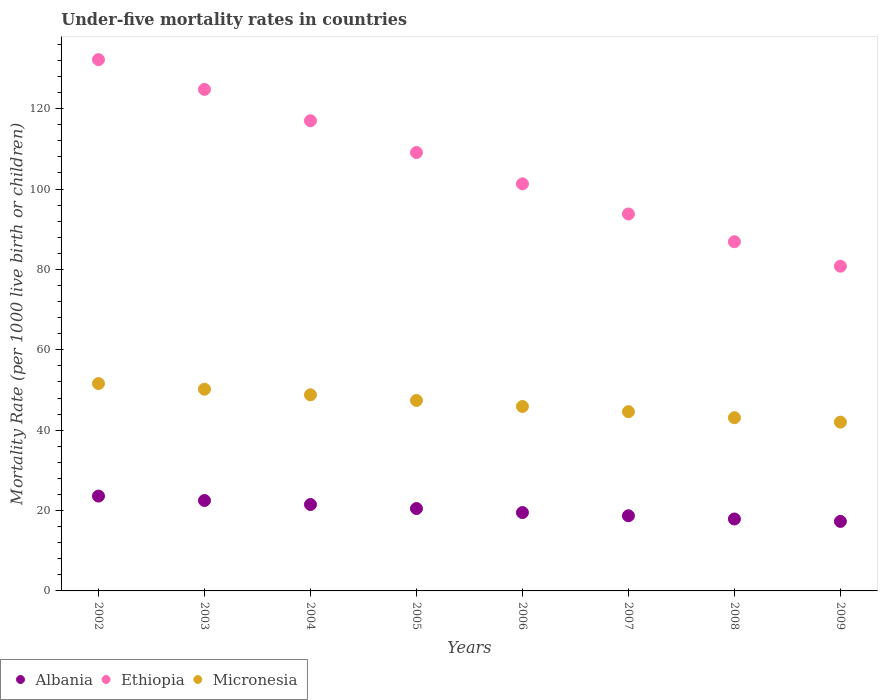How many different coloured dotlines are there?
Make the answer very short. 3. What is the under-five mortality rate in Micronesia in 2008?
Give a very brief answer. 43.1. Across all years, what is the maximum under-five mortality rate in Micronesia?
Provide a succinct answer. 51.6. Across all years, what is the minimum under-five mortality rate in Ethiopia?
Keep it short and to the point. 80.8. In which year was the under-five mortality rate in Ethiopia maximum?
Your answer should be very brief. 2002. What is the total under-five mortality rate in Albania in the graph?
Keep it short and to the point. 161.5. What is the difference between the under-five mortality rate in Ethiopia in 2004 and that in 2005?
Your response must be concise. 7.9. What is the difference between the under-five mortality rate in Ethiopia in 2002 and the under-five mortality rate in Micronesia in 2009?
Make the answer very short. 90.2. What is the average under-five mortality rate in Micronesia per year?
Give a very brief answer. 46.7. In the year 2007, what is the difference between the under-five mortality rate in Ethiopia and under-five mortality rate in Albania?
Offer a very short reply. 75.1. In how many years, is the under-five mortality rate in Ethiopia greater than 56?
Offer a terse response. 8. What is the ratio of the under-five mortality rate in Micronesia in 2004 to that in 2007?
Offer a very short reply. 1.09. Is the under-five mortality rate in Micronesia in 2005 less than that in 2009?
Offer a very short reply. No. Is the difference between the under-five mortality rate in Ethiopia in 2005 and 2009 greater than the difference between the under-five mortality rate in Albania in 2005 and 2009?
Your response must be concise. Yes. What is the difference between the highest and the second highest under-five mortality rate in Micronesia?
Offer a very short reply. 1.4. What is the difference between the highest and the lowest under-five mortality rate in Ethiopia?
Provide a short and direct response. 51.4. In how many years, is the under-five mortality rate in Ethiopia greater than the average under-five mortality rate in Ethiopia taken over all years?
Offer a very short reply. 4. Is the under-five mortality rate in Micronesia strictly less than the under-five mortality rate in Ethiopia over the years?
Provide a short and direct response. Yes. How many dotlines are there?
Keep it short and to the point. 3. What is the difference between two consecutive major ticks on the Y-axis?
Offer a terse response. 20. Are the values on the major ticks of Y-axis written in scientific E-notation?
Give a very brief answer. No. What is the title of the graph?
Keep it short and to the point. Under-five mortality rates in countries. Does "China" appear as one of the legend labels in the graph?
Your answer should be compact. No. What is the label or title of the X-axis?
Keep it short and to the point. Years. What is the label or title of the Y-axis?
Provide a succinct answer. Mortality Rate (per 1000 live birth or children). What is the Mortality Rate (per 1000 live birth or children) in Albania in 2002?
Give a very brief answer. 23.6. What is the Mortality Rate (per 1000 live birth or children) in Ethiopia in 2002?
Your answer should be very brief. 132.2. What is the Mortality Rate (per 1000 live birth or children) of Micronesia in 2002?
Provide a short and direct response. 51.6. What is the Mortality Rate (per 1000 live birth or children) of Albania in 2003?
Your response must be concise. 22.5. What is the Mortality Rate (per 1000 live birth or children) of Ethiopia in 2003?
Provide a short and direct response. 124.8. What is the Mortality Rate (per 1000 live birth or children) of Micronesia in 2003?
Provide a succinct answer. 50.2. What is the Mortality Rate (per 1000 live birth or children) in Ethiopia in 2004?
Ensure brevity in your answer.  117. What is the Mortality Rate (per 1000 live birth or children) of Micronesia in 2004?
Make the answer very short. 48.8. What is the Mortality Rate (per 1000 live birth or children) in Ethiopia in 2005?
Your response must be concise. 109.1. What is the Mortality Rate (per 1000 live birth or children) in Micronesia in 2005?
Your answer should be compact. 47.4. What is the Mortality Rate (per 1000 live birth or children) in Albania in 2006?
Your response must be concise. 19.5. What is the Mortality Rate (per 1000 live birth or children) in Ethiopia in 2006?
Your response must be concise. 101.3. What is the Mortality Rate (per 1000 live birth or children) of Micronesia in 2006?
Ensure brevity in your answer.  45.9. What is the Mortality Rate (per 1000 live birth or children) in Ethiopia in 2007?
Make the answer very short. 93.8. What is the Mortality Rate (per 1000 live birth or children) of Micronesia in 2007?
Provide a succinct answer. 44.6. What is the Mortality Rate (per 1000 live birth or children) of Albania in 2008?
Make the answer very short. 17.9. What is the Mortality Rate (per 1000 live birth or children) in Ethiopia in 2008?
Ensure brevity in your answer.  86.9. What is the Mortality Rate (per 1000 live birth or children) of Micronesia in 2008?
Make the answer very short. 43.1. What is the Mortality Rate (per 1000 live birth or children) of Albania in 2009?
Ensure brevity in your answer.  17.3. What is the Mortality Rate (per 1000 live birth or children) in Ethiopia in 2009?
Make the answer very short. 80.8. What is the Mortality Rate (per 1000 live birth or children) in Micronesia in 2009?
Make the answer very short. 42. Across all years, what is the maximum Mortality Rate (per 1000 live birth or children) in Albania?
Ensure brevity in your answer.  23.6. Across all years, what is the maximum Mortality Rate (per 1000 live birth or children) in Ethiopia?
Your answer should be compact. 132.2. Across all years, what is the maximum Mortality Rate (per 1000 live birth or children) in Micronesia?
Ensure brevity in your answer.  51.6. Across all years, what is the minimum Mortality Rate (per 1000 live birth or children) in Albania?
Give a very brief answer. 17.3. Across all years, what is the minimum Mortality Rate (per 1000 live birth or children) in Ethiopia?
Ensure brevity in your answer.  80.8. What is the total Mortality Rate (per 1000 live birth or children) in Albania in the graph?
Offer a very short reply. 161.5. What is the total Mortality Rate (per 1000 live birth or children) in Ethiopia in the graph?
Keep it short and to the point. 845.9. What is the total Mortality Rate (per 1000 live birth or children) in Micronesia in the graph?
Make the answer very short. 373.6. What is the difference between the Mortality Rate (per 1000 live birth or children) in Ethiopia in 2002 and that in 2003?
Give a very brief answer. 7.4. What is the difference between the Mortality Rate (per 1000 live birth or children) in Albania in 2002 and that in 2004?
Your response must be concise. 2.1. What is the difference between the Mortality Rate (per 1000 live birth or children) in Ethiopia in 2002 and that in 2004?
Your answer should be very brief. 15.2. What is the difference between the Mortality Rate (per 1000 live birth or children) in Micronesia in 2002 and that in 2004?
Provide a short and direct response. 2.8. What is the difference between the Mortality Rate (per 1000 live birth or children) in Ethiopia in 2002 and that in 2005?
Provide a succinct answer. 23.1. What is the difference between the Mortality Rate (per 1000 live birth or children) of Micronesia in 2002 and that in 2005?
Provide a short and direct response. 4.2. What is the difference between the Mortality Rate (per 1000 live birth or children) in Albania in 2002 and that in 2006?
Provide a succinct answer. 4.1. What is the difference between the Mortality Rate (per 1000 live birth or children) in Ethiopia in 2002 and that in 2006?
Keep it short and to the point. 30.9. What is the difference between the Mortality Rate (per 1000 live birth or children) of Ethiopia in 2002 and that in 2007?
Make the answer very short. 38.4. What is the difference between the Mortality Rate (per 1000 live birth or children) in Ethiopia in 2002 and that in 2008?
Ensure brevity in your answer.  45.3. What is the difference between the Mortality Rate (per 1000 live birth or children) of Micronesia in 2002 and that in 2008?
Offer a terse response. 8.5. What is the difference between the Mortality Rate (per 1000 live birth or children) in Albania in 2002 and that in 2009?
Provide a succinct answer. 6.3. What is the difference between the Mortality Rate (per 1000 live birth or children) of Ethiopia in 2002 and that in 2009?
Your answer should be compact. 51.4. What is the difference between the Mortality Rate (per 1000 live birth or children) in Micronesia in 2002 and that in 2009?
Provide a succinct answer. 9.6. What is the difference between the Mortality Rate (per 1000 live birth or children) of Ethiopia in 2003 and that in 2004?
Your answer should be compact. 7.8. What is the difference between the Mortality Rate (per 1000 live birth or children) in Micronesia in 2003 and that in 2004?
Give a very brief answer. 1.4. What is the difference between the Mortality Rate (per 1000 live birth or children) in Ethiopia in 2003 and that in 2005?
Provide a succinct answer. 15.7. What is the difference between the Mortality Rate (per 1000 live birth or children) in Albania in 2003 and that in 2006?
Make the answer very short. 3. What is the difference between the Mortality Rate (per 1000 live birth or children) in Ethiopia in 2003 and that in 2006?
Provide a succinct answer. 23.5. What is the difference between the Mortality Rate (per 1000 live birth or children) in Micronesia in 2003 and that in 2006?
Provide a succinct answer. 4.3. What is the difference between the Mortality Rate (per 1000 live birth or children) in Albania in 2003 and that in 2007?
Offer a terse response. 3.8. What is the difference between the Mortality Rate (per 1000 live birth or children) of Micronesia in 2003 and that in 2007?
Provide a short and direct response. 5.6. What is the difference between the Mortality Rate (per 1000 live birth or children) of Albania in 2003 and that in 2008?
Offer a terse response. 4.6. What is the difference between the Mortality Rate (per 1000 live birth or children) in Ethiopia in 2003 and that in 2008?
Give a very brief answer. 37.9. What is the difference between the Mortality Rate (per 1000 live birth or children) in Albania in 2003 and that in 2009?
Provide a short and direct response. 5.2. What is the difference between the Mortality Rate (per 1000 live birth or children) in Ethiopia in 2003 and that in 2009?
Your answer should be very brief. 44. What is the difference between the Mortality Rate (per 1000 live birth or children) in Ethiopia in 2004 and that in 2005?
Give a very brief answer. 7.9. What is the difference between the Mortality Rate (per 1000 live birth or children) in Albania in 2004 and that in 2006?
Make the answer very short. 2. What is the difference between the Mortality Rate (per 1000 live birth or children) of Ethiopia in 2004 and that in 2006?
Offer a terse response. 15.7. What is the difference between the Mortality Rate (per 1000 live birth or children) in Albania in 2004 and that in 2007?
Give a very brief answer. 2.8. What is the difference between the Mortality Rate (per 1000 live birth or children) of Ethiopia in 2004 and that in 2007?
Ensure brevity in your answer.  23.2. What is the difference between the Mortality Rate (per 1000 live birth or children) of Micronesia in 2004 and that in 2007?
Your answer should be very brief. 4.2. What is the difference between the Mortality Rate (per 1000 live birth or children) in Albania in 2004 and that in 2008?
Make the answer very short. 3.6. What is the difference between the Mortality Rate (per 1000 live birth or children) of Ethiopia in 2004 and that in 2008?
Your answer should be compact. 30.1. What is the difference between the Mortality Rate (per 1000 live birth or children) in Micronesia in 2004 and that in 2008?
Offer a very short reply. 5.7. What is the difference between the Mortality Rate (per 1000 live birth or children) in Albania in 2004 and that in 2009?
Make the answer very short. 4.2. What is the difference between the Mortality Rate (per 1000 live birth or children) in Ethiopia in 2004 and that in 2009?
Offer a very short reply. 36.2. What is the difference between the Mortality Rate (per 1000 live birth or children) in Ethiopia in 2005 and that in 2006?
Make the answer very short. 7.8. What is the difference between the Mortality Rate (per 1000 live birth or children) in Albania in 2005 and that in 2009?
Make the answer very short. 3.2. What is the difference between the Mortality Rate (per 1000 live birth or children) of Ethiopia in 2005 and that in 2009?
Your answer should be compact. 28.3. What is the difference between the Mortality Rate (per 1000 live birth or children) of Micronesia in 2006 and that in 2007?
Give a very brief answer. 1.3. What is the difference between the Mortality Rate (per 1000 live birth or children) of Albania in 2006 and that in 2008?
Keep it short and to the point. 1.6. What is the difference between the Mortality Rate (per 1000 live birth or children) of Ethiopia in 2006 and that in 2008?
Make the answer very short. 14.4. What is the difference between the Mortality Rate (per 1000 live birth or children) of Micronesia in 2006 and that in 2009?
Give a very brief answer. 3.9. What is the difference between the Mortality Rate (per 1000 live birth or children) of Albania in 2007 and that in 2009?
Provide a short and direct response. 1.4. What is the difference between the Mortality Rate (per 1000 live birth or children) of Ethiopia in 2007 and that in 2009?
Your answer should be very brief. 13. What is the difference between the Mortality Rate (per 1000 live birth or children) of Micronesia in 2008 and that in 2009?
Provide a succinct answer. 1.1. What is the difference between the Mortality Rate (per 1000 live birth or children) in Albania in 2002 and the Mortality Rate (per 1000 live birth or children) in Ethiopia in 2003?
Offer a terse response. -101.2. What is the difference between the Mortality Rate (per 1000 live birth or children) in Albania in 2002 and the Mortality Rate (per 1000 live birth or children) in Micronesia in 2003?
Provide a succinct answer. -26.6. What is the difference between the Mortality Rate (per 1000 live birth or children) in Ethiopia in 2002 and the Mortality Rate (per 1000 live birth or children) in Micronesia in 2003?
Your answer should be very brief. 82. What is the difference between the Mortality Rate (per 1000 live birth or children) in Albania in 2002 and the Mortality Rate (per 1000 live birth or children) in Ethiopia in 2004?
Your response must be concise. -93.4. What is the difference between the Mortality Rate (per 1000 live birth or children) of Albania in 2002 and the Mortality Rate (per 1000 live birth or children) of Micronesia in 2004?
Your answer should be very brief. -25.2. What is the difference between the Mortality Rate (per 1000 live birth or children) in Ethiopia in 2002 and the Mortality Rate (per 1000 live birth or children) in Micronesia in 2004?
Ensure brevity in your answer.  83.4. What is the difference between the Mortality Rate (per 1000 live birth or children) in Albania in 2002 and the Mortality Rate (per 1000 live birth or children) in Ethiopia in 2005?
Offer a very short reply. -85.5. What is the difference between the Mortality Rate (per 1000 live birth or children) in Albania in 2002 and the Mortality Rate (per 1000 live birth or children) in Micronesia in 2005?
Ensure brevity in your answer.  -23.8. What is the difference between the Mortality Rate (per 1000 live birth or children) of Ethiopia in 2002 and the Mortality Rate (per 1000 live birth or children) of Micronesia in 2005?
Keep it short and to the point. 84.8. What is the difference between the Mortality Rate (per 1000 live birth or children) in Albania in 2002 and the Mortality Rate (per 1000 live birth or children) in Ethiopia in 2006?
Your response must be concise. -77.7. What is the difference between the Mortality Rate (per 1000 live birth or children) of Albania in 2002 and the Mortality Rate (per 1000 live birth or children) of Micronesia in 2006?
Provide a succinct answer. -22.3. What is the difference between the Mortality Rate (per 1000 live birth or children) in Ethiopia in 2002 and the Mortality Rate (per 1000 live birth or children) in Micronesia in 2006?
Your response must be concise. 86.3. What is the difference between the Mortality Rate (per 1000 live birth or children) in Albania in 2002 and the Mortality Rate (per 1000 live birth or children) in Ethiopia in 2007?
Provide a succinct answer. -70.2. What is the difference between the Mortality Rate (per 1000 live birth or children) in Albania in 2002 and the Mortality Rate (per 1000 live birth or children) in Micronesia in 2007?
Give a very brief answer. -21. What is the difference between the Mortality Rate (per 1000 live birth or children) in Ethiopia in 2002 and the Mortality Rate (per 1000 live birth or children) in Micronesia in 2007?
Keep it short and to the point. 87.6. What is the difference between the Mortality Rate (per 1000 live birth or children) in Albania in 2002 and the Mortality Rate (per 1000 live birth or children) in Ethiopia in 2008?
Your answer should be very brief. -63.3. What is the difference between the Mortality Rate (per 1000 live birth or children) in Albania in 2002 and the Mortality Rate (per 1000 live birth or children) in Micronesia in 2008?
Ensure brevity in your answer.  -19.5. What is the difference between the Mortality Rate (per 1000 live birth or children) of Ethiopia in 2002 and the Mortality Rate (per 1000 live birth or children) of Micronesia in 2008?
Provide a short and direct response. 89.1. What is the difference between the Mortality Rate (per 1000 live birth or children) of Albania in 2002 and the Mortality Rate (per 1000 live birth or children) of Ethiopia in 2009?
Ensure brevity in your answer.  -57.2. What is the difference between the Mortality Rate (per 1000 live birth or children) of Albania in 2002 and the Mortality Rate (per 1000 live birth or children) of Micronesia in 2009?
Your answer should be compact. -18.4. What is the difference between the Mortality Rate (per 1000 live birth or children) of Ethiopia in 2002 and the Mortality Rate (per 1000 live birth or children) of Micronesia in 2009?
Your answer should be compact. 90.2. What is the difference between the Mortality Rate (per 1000 live birth or children) of Albania in 2003 and the Mortality Rate (per 1000 live birth or children) of Ethiopia in 2004?
Give a very brief answer. -94.5. What is the difference between the Mortality Rate (per 1000 live birth or children) in Albania in 2003 and the Mortality Rate (per 1000 live birth or children) in Micronesia in 2004?
Give a very brief answer. -26.3. What is the difference between the Mortality Rate (per 1000 live birth or children) in Ethiopia in 2003 and the Mortality Rate (per 1000 live birth or children) in Micronesia in 2004?
Provide a short and direct response. 76. What is the difference between the Mortality Rate (per 1000 live birth or children) of Albania in 2003 and the Mortality Rate (per 1000 live birth or children) of Ethiopia in 2005?
Keep it short and to the point. -86.6. What is the difference between the Mortality Rate (per 1000 live birth or children) of Albania in 2003 and the Mortality Rate (per 1000 live birth or children) of Micronesia in 2005?
Ensure brevity in your answer.  -24.9. What is the difference between the Mortality Rate (per 1000 live birth or children) in Ethiopia in 2003 and the Mortality Rate (per 1000 live birth or children) in Micronesia in 2005?
Your answer should be very brief. 77.4. What is the difference between the Mortality Rate (per 1000 live birth or children) in Albania in 2003 and the Mortality Rate (per 1000 live birth or children) in Ethiopia in 2006?
Offer a terse response. -78.8. What is the difference between the Mortality Rate (per 1000 live birth or children) in Albania in 2003 and the Mortality Rate (per 1000 live birth or children) in Micronesia in 2006?
Your answer should be compact. -23.4. What is the difference between the Mortality Rate (per 1000 live birth or children) in Ethiopia in 2003 and the Mortality Rate (per 1000 live birth or children) in Micronesia in 2006?
Your response must be concise. 78.9. What is the difference between the Mortality Rate (per 1000 live birth or children) of Albania in 2003 and the Mortality Rate (per 1000 live birth or children) of Ethiopia in 2007?
Make the answer very short. -71.3. What is the difference between the Mortality Rate (per 1000 live birth or children) of Albania in 2003 and the Mortality Rate (per 1000 live birth or children) of Micronesia in 2007?
Keep it short and to the point. -22.1. What is the difference between the Mortality Rate (per 1000 live birth or children) in Ethiopia in 2003 and the Mortality Rate (per 1000 live birth or children) in Micronesia in 2007?
Provide a succinct answer. 80.2. What is the difference between the Mortality Rate (per 1000 live birth or children) of Albania in 2003 and the Mortality Rate (per 1000 live birth or children) of Ethiopia in 2008?
Your response must be concise. -64.4. What is the difference between the Mortality Rate (per 1000 live birth or children) of Albania in 2003 and the Mortality Rate (per 1000 live birth or children) of Micronesia in 2008?
Provide a short and direct response. -20.6. What is the difference between the Mortality Rate (per 1000 live birth or children) of Ethiopia in 2003 and the Mortality Rate (per 1000 live birth or children) of Micronesia in 2008?
Ensure brevity in your answer.  81.7. What is the difference between the Mortality Rate (per 1000 live birth or children) in Albania in 2003 and the Mortality Rate (per 1000 live birth or children) in Ethiopia in 2009?
Give a very brief answer. -58.3. What is the difference between the Mortality Rate (per 1000 live birth or children) of Albania in 2003 and the Mortality Rate (per 1000 live birth or children) of Micronesia in 2009?
Provide a short and direct response. -19.5. What is the difference between the Mortality Rate (per 1000 live birth or children) of Ethiopia in 2003 and the Mortality Rate (per 1000 live birth or children) of Micronesia in 2009?
Your answer should be very brief. 82.8. What is the difference between the Mortality Rate (per 1000 live birth or children) in Albania in 2004 and the Mortality Rate (per 1000 live birth or children) in Ethiopia in 2005?
Provide a short and direct response. -87.6. What is the difference between the Mortality Rate (per 1000 live birth or children) in Albania in 2004 and the Mortality Rate (per 1000 live birth or children) in Micronesia in 2005?
Your answer should be very brief. -25.9. What is the difference between the Mortality Rate (per 1000 live birth or children) in Ethiopia in 2004 and the Mortality Rate (per 1000 live birth or children) in Micronesia in 2005?
Give a very brief answer. 69.6. What is the difference between the Mortality Rate (per 1000 live birth or children) of Albania in 2004 and the Mortality Rate (per 1000 live birth or children) of Ethiopia in 2006?
Your answer should be compact. -79.8. What is the difference between the Mortality Rate (per 1000 live birth or children) of Albania in 2004 and the Mortality Rate (per 1000 live birth or children) of Micronesia in 2006?
Make the answer very short. -24.4. What is the difference between the Mortality Rate (per 1000 live birth or children) of Ethiopia in 2004 and the Mortality Rate (per 1000 live birth or children) of Micronesia in 2006?
Your answer should be compact. 71.1. What is the difference between the Mortality Rate (per 1000 live birth or children) of Albania in 2004 and the Mortality Rate (per 1000 live birth or children) of Ethiopia in 2007?
Your answer should be compact. -72.3. What is the difference between the Mortality Rate (per 1000 live birth or children) in Albania in 2004 and the Mortality Rate (per 1000 live birth or children) in Micronesia in 2007?
Your answer should be compact. -23.1. What is the difference between the Mortality Rate (per 1000 live birth or children) in Ethiopia in 2004 and the Mortality Rate (per 1000 live birth or children) in Micronesia in 2007?
Ensure brevity in your answer.  72.4. What is the difference between the Mortality Rate (per 1000 live birth or children) of Albania in 2004 and the Mortality Rate (per 1000 live birth or children) of Ethiopia in 2008?
Offer a very short reply. -65.4. What is the difference between the Mortality Rate (per 1000 live birth or children) in Albania in 2004 and the Mortality Rate (per 1000 live birth or children) in Micronesia in 2008?
Ensure brevity in your answer.  -21.6. What is the difference between the Mortality Rate (per 1000 live birth or children) in Ethiopia in 2004 and the Mortality Rate (per 1000 live birth or children) in Micronesia in 2008?
Offer a very short reply. 73.9. What is the difference between the Mortality Rate (per 1000 live birth or children) in Albania in 2004 and the Mortality Rate (per 1000 live birth or children) in Ethiopia in 2009?
Keep it short and to the point. -59.3. What is the difference between the Mortality Rate (per 1000 live birth or children) in Albania in 2004 and the Mortality Rate (per 1000 live birth or children) in Micronesia in 2009?
Offer a very short reply. -20.5. What is the difference between the Mortality Rate (per 1000 live birth or children) of Albania in 2005 and the Mortality Rate (per 1000 live birth or children) of Ethiopia in 2006?
Your answer should be compact. -80.8. What is the difference between the Mortality Rate (per 1000 live birth or children) of Albania in 2005 and the Mortality Rate (per 1000 live birth or children) of Micronesia in 2006?
Provide a succinct answer. -25.4. What is the difference between the Mortality Rate (per 1000 live birth or children) of Ethiopia in 2005 and the Mortality Rate (per 1000 live birth or children) of Micronesia in 2006?
Ensure brevity in your answer.  63.2. What is the difference between the Mortality Rate (per 1000 live birth or children) of Albania in 2005 and the Mortality Rate (per 1000 live birth or children) of Ethiopia in 2007?
Offer a terse response. -73.3. What is the difference between the Mortality Rate (per 1000 live birth or children) of Albania in 2005 and the Mortality Rate (per 1000 live birth or children) of Micronesia in 2007?
Ensure brevity in your answer.  -24.1. What is the difference between the Mortality Rate (per 1000 live birth or children) in Ethiopia in 2005 and the Mortality Rate (per 1000 live birth or children) in Micronesia in 2007?
Make the answer very short. 64.5. What is the difference between the Mortality Rate (per 1000 live birth or children) in Albania in 2005 and the Mortality Rate (per 1000 live birth or children) in Ethiopia in 2008?
Provide a short and direct response. -66.4. What is the difference between the Mortality Rate (per 1000 live birth or children) of Albania in 2005 and the Mortality Rate (per 1000 live birth or children) of Micronesia in 2008?
Ensure brevity in your answer.  -22.6. What is the difference between the Mortality Rate (per 1000 live birth or children) in Albania in 2005 and the Mortality Rate (per 1000 live birth or children) in Ethiopia in 2009?
Ensure brevity in your answer.  -60.3. What is the difference between the Mortality Rate (per 1000 live birth or children) in Albania in 2005 and the Mortality Rate (per 1000 live birth or children) in Micronesia in 2009?
Provide a short and direct response. -21.5. What is the difference between the Mortality Rate (per 1000 live birth or children) of Ethiopia in 2005 and the Mortality Rate (per 1000 live birth or children) of Micronesia in 2009?
Your response must be concise. 67.1. What is the difference between the Mortality Rate (per 1000 live birth or children) of Albania in 2006 and the Mortality Rate (per 1000 live birth or children) of Ethiopia in 2007?
Your answer should be compact. -74.3. What is the difference between the Mortality Rate (per 1000 live birth or children) in Albania in 2006 and the Mortality Rate (per 1000 live birth or children) in Micronesia in 2007?
Make the answer very short. -25.1. What is the difference between the Mortality Rate (per 1000 live birth or children) of Ethiopia in 2006 and the Mortality Rate (per 1000 live birth or children) of Micronesia in 2007?
Keep it short and to the point. 56.7. What is the difference between the Mortality Rate (per 1000 live birth or children) in Albania in 2006 and the Mortality Rate (per 1000 live birth or children) in Ethiopia in 2008?
Ensure brevity in your answer.  -67.4. What is the difference between the Mortality Rate (per 1000 live birth or children) of Albania in 2006 and the Mortality Rate (per 1000 live birth or children) of Micronesia in 2008?
Provide a succinct answer. -23.6. What is the difference between the Mortality Rate (per 1000 live birth or children) in Ethiopia in 2006 and the Mortality Rate (per 1000 live birth or children) in Micronesia in 2008?
Give a very brief answer. 58.2. What is the difference between the Mortality Rate (per 1000 live birth or children) of Albania in 2006 and the Mortality Rate (per 1000 live birth or children) of Ethiopia in 2009?
Your answer should be very brief. -61.3. What is the difference between the Mortality Rate (per 1000 live birth or children) of Albania in 2006 and the Mortality Rate (per 1000 live birth or children) of Micronesia in 2009?
Keep it short and to the point. -22.5. What is the difference between the Mortality Rate (per 1000 live birth or children) in Ethiopia in 2006 and the Mortality Rate (per 1000 live birth or children) in Micronesia in 2009?
Offer a terse response. 59.3. What is the difference between the Mortality Rate (per 1000 live birth or children) in Albania in 2007 and the Mortality Rate (per 1000 live birth or children) in Ethiopia in 2008?
Provide a short and direct response. -68.2. What is the difference between the Mortality Rate (per 1000 live birth or children) in Albania in 2007 and the Mortality Rate (per 1000 live birth or children) in Micronesia in 2008?
Your response must be concise. -24.4. What is the difference between the Mortality Rate (per 1000 live birth or children) of Ethiopia in 2007 and the Mortality Rate (per 1000 live birth or children) of Micronesia in 2008?
Give a very brief answer. 50.7. What is the difference between the Mortality Rate (per 1000 live birth or children) of Albania in 2007 and the Mortality Rate (per 1000 live birth or children) of Ethiopia in 2009?
Offer a very short reply. -62.1. What is the difference between the Mortality Rate (per 1000 live birth or children) of Albania in 2007 and the Mortality Rate (per 1000 live birth or children) of Micronesia in 2009?
Your response must be concise. -23.3. What is the difference between the Mortality Rate (per 1000 live birth or children) of Ethiopia in 2007 and the Mortality Rate (per 1000 live birth or children) of Micronesia in 2009?
Offer a terse response. 51.8. What is the difference between the Mortality Rate (per 1000 live birth or children) of Albania in 2008 and the Mortality Rate (per 1000 live birth or children) of Ethiopia in 2009?
Your response must be concise. -62.9. What is the difference between the Mortality Rate (per 1000 live birth or children) in Albania in 2008 and the Mortality Rate (per 1000 live birth or children) in Micronesia in 2009?
Keep it short and to the point. -24.1. What is the difference between the Mortality Rate (per 1000 live birth or children) of Ethiopia in 2008 and the Mortality Rate (per 1000 live birth or children) of Micronesia in 2009?
Provide a succinct answer. 44.9. What is the average Mortality Rate (per 1000 live birth or children) in Albania per year?
Offer a very short reply. 20.19. What is the average Mortality Rate (per 1000 live birth or children) of Ethiopia per year?
Your answer should be very brief. 105.74. What is the average Mortality Rate (per 1000 live birth or children) in Micronesia per year?
Your answer should be very brief. 46.7. In the year 2002, what is the difference between the Mortality Rate (per 1000 live birth or children) of Albania and Mortality Rate (per 1000 live birth or children) of Ethiopia?
Your answer should be very brief. -108.6. In the year 2002, what is the difference between the Mortality Rate (per 1000 live birth or children) of Albania and Mortality Rate (per 1000 live birth or children) of Micronesia?
Provide a succinct answer. -28. In the year 2002, what is the difference between the Mortality Rate (per 1000 live birth or children) in Ethiopia and Mortality Rate (per 1000 live birth or children) in Micronesia?
Offer a very short reply. 80.6. In the year 2003, what is the difference between the Mortality Rate (per 1000 live birth or children) of Albania and Mortality Rate (per 1000 live birth or children) of Ethiopia?
Keep it short and to the point. -102.3. In the year 2003, what is the difference between the Mortality Rate (per 1000 live birth or children) of Albania and Mortality Rate (per 1000 live birth or children) of Micronesia?
Your answer should be compact. -27.7. In the year 2003, what is the difference between the Mortality Rate (per 1000 live birth or children) in Ethiopia and Mortality Rate (per 1000 live birth or children) in Micronesia?
Ensure brevity in your answer.  74.6. In the year 2004, what is the difference between the Mortality Rate (per 1000 live birth or children) in Albania and Mortality Rate (per 1000 live birth or children) in Ethiopia?
Your response must be concise. -95.5. In the year 2004, what is the difference between the Mortality Rate (per 1000 live birth or children) of Albania and Mortality Rate (per 1000 live birth or children) of Micronesia?
Give a very brief answer. -27.3. In the year 2004, what is the difference between the Mortality Rate (per 1000 live birth or children) in Ethiopia and Mortality Rate (per 1000 live birth or children) in Micronesia?
Give a very brief answer. 68.2. In the year 2005, what is the difference between the Mortality Rate (per 1000 live birth or children) in Albania and Mortality Rate (per 1000 live birth or children) in Ethiopia?
Offer a terse response. -88.6. In the year 2005, what is the difference between the Mortality Rate (per 1000 live birth or children) in Albania and Mortality Rate (per 1000 live birth or children) in Micronesia?
Offer a terse response. -26.9. In the year 2005, what is the difference between the Mortality Rate (per 1000 live birth or children) in Ethiopia and Mortality Rate (per 1000 live birth or children) in Micronesia?
Provide a succinct answer. 61.7. In the year 2006, what is the difference between the Mortality Rate (per 1000 live birth or children) in Albania and Mortality Rate (per 1000 live birth or children) in Ethiopia?
Your answer should be very brief. -81.8. In the year 2006, what is the difference between the Mortality Rate (per 1000 live birth or children) of Albania and Mortality Rate (per 1000 live birth or children) of Micronesia?
Offer a terse response. -26.4. In the year 2006, what is the difference between the Mortality Rate (per 1000 live birth or children) of Ethiopia and Mortality Rate (per 1000 live birth or children) of Micronesia?
Give a very brief answer. 55.4. In the year 2007, what is the difference between the Mortality Rate (per 1000 live birth or children) of Albania and Mortality Rate (per 1000 live birth or children) of Ethiopia?
Offer a terse response. -75.1. In the year 2007, what is the difference between the Mortality Rate (per 1000 live birth or children) of Albania and Mortality Rate (per 1000 live birth or children) of Micronesia?
Give a very brief answer. -25.9. In the year 2007, what is the difference between the Mortality Rate (per 1000 live birth or children) in Ethiopia and Mortality Rate (per 1000 live birth or children) in Micronesia?
Offer a very short reply. 49.2. In the year 2008, what is the difference between the Mortality Rate (per 1000 live birth or children) in Albania and Mortality Rate (per 1000 live birth or children) in Ethiopia?
Keep it short and to the point. -69. In the year 2008, what is the difference between the Mortality Rate (per 1000 live birth or children) in Albania and Mortality Rate (per 1000 live birth or children) in Micronesia?
Your response must be concise. -25.2. In the year 2008, what is the difference between the Mortality Rate (per 1000 live birth or children) of Ethiopia and Mortality Rate (per 1000 live birth or children) of Micronesia?
Give a very brief answer. 43.8. In the year 2009, what is the difference between the Mortality Rate (per 1000 live birth or children) in Albania and Mortality Rate (per 1000 live birth or children) in Ethiopia?
Offer a very short reply. -63.5. In the year 2009, what is the difference between the Mortality Rate (per 1000 live birth or children) in Albania and Mortality Rate (per 1000 live birth or children) in Micronesia?
Your response must be concise. -24.7. In the year 2009, what is the difference between the Mortality Rate (per 1000 live birth or children) in Ethiopia and Mortality Rate (per 1000 live birth or children) in Micronesia?
Ensure brevity in your answer.  38.8. What is the ratio of the Mortality Rate (per 1000 live birth or children) in Albania in 2002 to that in 2003?
Your answer should be very brief. 1.05. What is the ratio of the Mortality Rate (per 1000 live birth or children) of Ethiopia in 2002 to that in 2003?
Your answer should be compact. 1.06. What is the ratio of the Mortality Rate (per 1000 live birth or children) in Micronesia in 2002 to that in 2003?
Give a very brief answer. 1.03. What is the ratio of the Mortality Rate (per 1000 live birth or children) of Albania in 2002 to that in 2004?
Offer a terse response. 1.1. What is the ratio of the Mortality Rate (per 1000 live birth or children) of Ethiopia in 2002 to that in 2004?
Your answer should be compact. 1.13. What is the ratio of the Mortality Rate (per 1000 live birth or children) in Micronesia in 2002 to that in 2004?
Your response must be concise. 1.06. What is the ratio of the Mortality Rate (per 1000 live birth or children) of Albania in 2002 to that in 2005?
Your answer should be very brief. 1.15. What is the ratio of the Mortality Rate (per 1000 live birth or children) in Ethiopia in 2002 to that in 2005?
Make the answer very short. 1.21. What is the ratio of the Mortality Rate (per 1000 live birth or children) in Micronesia in 2002 to that in 2005?
Offer a terse response. 1.09. What is the ratio of the Mortality Rate (per 1000 live birth or children) in Albania in 2002 to that in 2006?
Provide a short and direct response. 1.21. What is the ratio of the Mortality Rate (per 1000 live birth or children) of Ethiopia in 2002 to that in 2006?
Offer a very short reply. 1.3. What is the ratio of the Mortality Rate (per 1000 live birth or children) in Micronesia in 2002 to that in 2006?
Offer a terse response. 1.12. What is the ratio of the Mortality Rate (per 1000 live birth or children) of Albania in 2002 to that in 2007?
Provide a succinct answer. 1.26. What is the ratio of the Mortality Rate (per 1000 live birth or children) in Ethiopia in 2002 to that in 2007?
Give a very brief answer. 1.41. What is the ratio of the Mortality Rate (per 1000 live birth or children) of Micronesia in 2002 to that in 2007?
Offer a terse response. 1.16. What is the ratio of the Mortality Rate (per 1000 live birth or children) in Albania in 2002 to that in 2008?
Make the answer very short. 1.32. What is the ratio of the Mortality Rate (per 1000 live birth or children) of Ethiopia in 2002 to that in 2008?
Keep it short and to the point. 1.52. What is the ratio of the Mortality Rate (per 1000 live birth or children) of Micronesia in 2002 to that in 2008?
Offer a very short reply. 1.2. What is the ratio of the Mortality Rate (per 1000 live birth or children) in Albania in 2002 to that in 2009?
Make the answer very short. 1.36. What is the ratio of the Mortality Rate (per 1000 live birth or children) in Ethiopia in 2002 to that in 2009?
Provide a short and direct response. 1.64. What is the ratio of the Mortality Rate (per 1000 live birth or children) in Micronesia in 2002 to that in 2009?
Offer a terse response. 1.23. What is the ratio of the Mortality Rate (per 1000 live birth or children) in Albania in 2003 to that in 2004?
Offer a terse response. 1.05. What is the ratio of the Mortality Rate (per 1000 live birth or children) in Ethiopia in 2003 to that in 2004?
Your response must be concise. 1.07. What is the ratio of the Mortality Rate (per 1000 live birth or children) in Micronesia in 2003 to that in 2004?
Keep it short and to the point. 1.03. What is the ratio of the Mortality Rate (per 1000 live birth or children) in Albania in 2003 to that in 2005?
Provide a succinct answer. 1.1. What is the ratio of the Mortality Rate (per 1000 live birth or children) in Ethiopia in 2003 to that in 2005?
Your response must be concise. 1.14. What is the ratio of the Mortality Rate (per 1000 live birth or children) of Micronesia in 2003 to that in 2005?
Your answer should be very brief. 1.06. What is the ratio of the Mortality Rate (per 1000 live birth or children) of Albania in 2003 to that in 2006?
Keep it short and to the point. 1.15. What is the ratio of the Mortality Rate (per 1000 live birth or children) of Ethiopia in 2003 to that in 2006?
Your response must be concise. 1.23. What is the ratio of the Mortality Rate (per 1000 live birth or children) in Micronesia in 2003 to that in 2006?
Provide a short and direct response. 1.09. What is the ratio of the Mortality Rate (per 1000 live birth or children) of Albania in 2003 to that in 2007?
Make the answer very short. 1.2. What is the ratio of the Mortality Rate (per 1000 live birth or children) of Ethiopia in 2003 to that in 2007?
Make the answer very short. 1.33. What is the ratio of the Mortality Rate (per 1000 live birth or children) in Micronesia in 2003 to that in 2007?
Ensure brevity in your answer.  1.13. What is the ratio of the Mortality Rate (per 1000 live birth or children) of Albania in 2003 to that in 2008?
Your answer should be very brief. 1.26. What is the ratio of the Mortality Rate (per 1000 live birth or children) of Ethiopia in 2003 to that in 2008?
Your answer should be very brief. 1.44. What is the ratio of the Mortality Rate (per 1000 live birth or children) of Micronesia in 2003 to that in 2008?
Your answer should be compact. 1.16. What is the ratio of the Mortality Rate (per 1000 live birth or children) of Albania in 2003 to that in 2009?
Your response must be concise. 1.3. What is the ratio of the Mortality Rate (per 1000 live birth or children) of Ethiopia in 2003 to that in 2009?
Provide a short and direct response. 1.54. What is the ratio of the Mortality Rate (per 1000 live birth or children) of Micronesia in 2003 to that in 2009?
Offer a terse response. 1.2. What is the ratio of the Mortality Rate (per 1000 live birth or children) in Albania in 2004 to that in 2005?
Offer a very short reply. 1.05. What is the ratio of the Mortality Rate (per 1000 live birth or children) in Ethiopia in 2004 to that in 2005?
Offer a very short reply. 1.07. What is the ratio of the Mortality Rate (per 1000 live birth or children) of Micronesia in 2004 to that in 2005?
Your answer should be very brief. 1.03. What is the ratio of the Mortality Rate (per 1000 live birth or children) of Albania in 2004 to that in 2006?
Make the answer very short. 1.1. What is the ratio of the Mortality Rate (per 1000 live birth or children) in Ethiopia in 2004 to that in 2006?
Your answer should be compact. 1.16. What is the ratio of the Mortality Rate (per 1000 live birth or children) of Micronesia in 2004 to that in 2006?
Keep it short and to the point. 1.06. What is the ratio of the Mortality Rate (per 1000 live birth or children) of Albania in 2004 to that in 2007?
Ensure brevity in your answer.  1.15. What is the ratio of the Mortality Rate (per 1000 live birth or children) in Ethiopia in 2004 to that in 2007?
Give a very brief answer. 1.25. What is the ratio of the Mortality Rate (per 1000 live birth or children) in Micronesia in 2004 to that in 2007?
Make the answer very short. 1.09. What is the ratio of the Mortality Rate (per 1000 live birth or children) of Albania in 2004 to that in 2008?
Provide a succinct answer. 1.2. What is the ratio of the Mortality Rate (per 1000 live birth or children) of Ethiopia in 2004 to that in 2008?
Your answer should be very brief. 1.35. What is the ratio of the Mortality Rate (per 1000 live birth or children) in Micronesia in 2004 to that in 2008?
Provide a succinct answer. 1.13. What is the ratio of the Mortality Rate (per 1000 live birth or children) in Albania in 2004 to that in 2009?
Make the answer very short. 1.24. What is the ratio of the Mortality Rate (per 1000 live birth or children) in Ethiopia in 2004 to that in 2009?
Provide a succinct answer. 1.45. What is the ratio of the Mortality Rate (per 1000 live birth or children) of Micronesia in 2004 to that in 2009?
Ensure brevity in your answer.  1.16. What is the ratio of the Mortality Rate (per 1000 live birth or children) in Albania in 2005 to that in 2006?
Give a very brief answer. 1.05. What is the ratio of the Mortality Rate (per 1000 live birth or children) of Ethiopia in 2005 to that in 2006?
Make the answer very short. 1.08. What is the ratio of the Mortality Rate (per 1000 live birth or children) of Micronesia in 2005 to that in 2006?
Your response must be concise. 1.03. What is the ratio of the Mortality Rate (per 1000 live birth or children) in Albania in 2005 to that in 2007?
Provide a succinct answer. 1.1. What is the ratio of the Mortality Rate (per 1000 live birth or children) of Ethiopia in 2005 to that in 2007?
Your answer should be very brief. 1.16. What is the ratio of the Mortality Rate (per 1000 live birth or children) of Micronesia in 2005 to that in 2007?
Make the answer very short. 1.06. What is the ratio of the Mortality Rate (per 1000 live birth or children) in Albania in 2005 to that in 2008?
Your answer should be very brief. 1.15. What is the ratio of the Mortality Rate (per 1000 live birth or children) in Ethiopia in 2005 to that in 2008?
Provide a succinct answer. 1.26. What is the ratio of the Mortality Rate (per 1000 live birth or children) in Micronesia in 2005 to that in 2008?
Give a very brief answer. 1.1. What is the ratio of the Mortality Rate (per 1000 live birth or children) in Albania in 2005 to that in 2009?
Your answer should be compact. 1.19. What is the ratio of the Mortality Rate (per 1000 live birth or children) in Ethiopia in 2005 to that in 2009?
Your answer should be very brief. 1.35. What is the ratio of the Mortality Rate (per 1000 live birth or children) in Micronesia in 2005 to that in 2009?
Your answer should be compact. 1.13. What is the ratio of the Mortality Rate (per 1000 live birth or children) of Albania in 2006 to that in 2007?
Offer a very short reply. 1.04. What is the ratio of the Mortality Rate (per 1000 live birth or children) of Ethiopia in 2006 to that in 2007?
Ensure brevity in your answer.  1.08. What is the ratio of the Mortality Rate (per 1000 live birth or children) of Micronesia in 2006 to that in 2007?
Make the answer very short. 1.03. What is the ratio of the Mortality Rate (per 1000 live birth or children) in Albania in 2006 to that in 2008?
Make the answer very short. 1.09. What is the ratio of the Mortality Rate (per 1000 live birth or children) in Ethiopia in 2006 to that in 2008?
Provide a short and direct response. 1.17. What is the ratio of the Mortality Rate (per 1000 live birth or children) in Micronesia in 2006 to that in 2008?
Give a very brief answer. 1.06. What is the ratio of the Mortality Rate (per 1000 live birth or children) in Albania in 2006 to that in 2009?
Your answer should be very brief. 1.13. What is the ratio of the Mortality Rate (per 1000 live birth or children) in Ethiopia in 2006 to that in 2009?
Give a very brief answer. 1.25. What is the ratio of the Mortality Rate (per 1000 live birth or children) in Micronesia in 2006 to that in 2009?
Give a very brief answer. 1.09. What is the ratio of the Mortality Rate (per 1000 live birth or children) in Albania in 2007 to that in 2008?
Provide a succinct answer. 1.04. What is the ratio of the Mortality Rate (per 1000 live birth or children) of Ethiopia in 2007 to that in 2008?
Make the answer very short. 1.08. What is the ratio of the Mortality Rate (per 1000 live birth or children) of Micronesia in 2007 to that in 2008?
Make the answer very short. 1.03. What is the ratio of the Mortality Rate (per 1000 live birth or children) in Albania in 2007 to that in 2009?
Offer a terse response. 1.08. What is the ratio of the Mortality Rate (per 1000 live birth or children) in Ethiopia in 2007 to that in 2009?
Offer a terse response. 1.16. What is the ratio of the Mortality Rate (per 1000 live birth or children) in Micronesia in 2007 to that in 2009?
Make the answer very short. 1.06. What is the ratio of the Mortality Rate (per 1000 live birth or children) of Albania in 2008 to that in 2009?
Offer a very short reply. 1.03. What is the ratio of the Mortality Rate (per 1000 live birth or children) in Ethiopia in 2008 to that in 2009?
Offer a terse response. 1.08. What is the ratio of the Mortality Rate (per 1000 live birth or children) of Micronesia in 2008 to that in 2009?
Give a very brief answer. 1.03. What is the difference between the highest and the second highest Mortality Rate (per 1000 live birth or children) of Albania?
Provide a short and direct response. 1.1. What is the difference between the highest and the second highest Mortality Rate (per 1000 live birth or children) in Micronesia?
Give a very brief answer. 1.4. What is the difference between the highest and the lowest Mortality Rate (per 1000 live birth or children) in Albania?
Your answer should be compact. 6.3. What is the difference between the highest and the lowest Mortality Rate (per 1000 live birth or children) in Ethiopia?
Offer a very short reply. 51.4. What is the difference between the highest and the lowest Mortality Rate (per 1000 live birth or children) of Micronesia?
Your answer should be very brief. 9.6. 